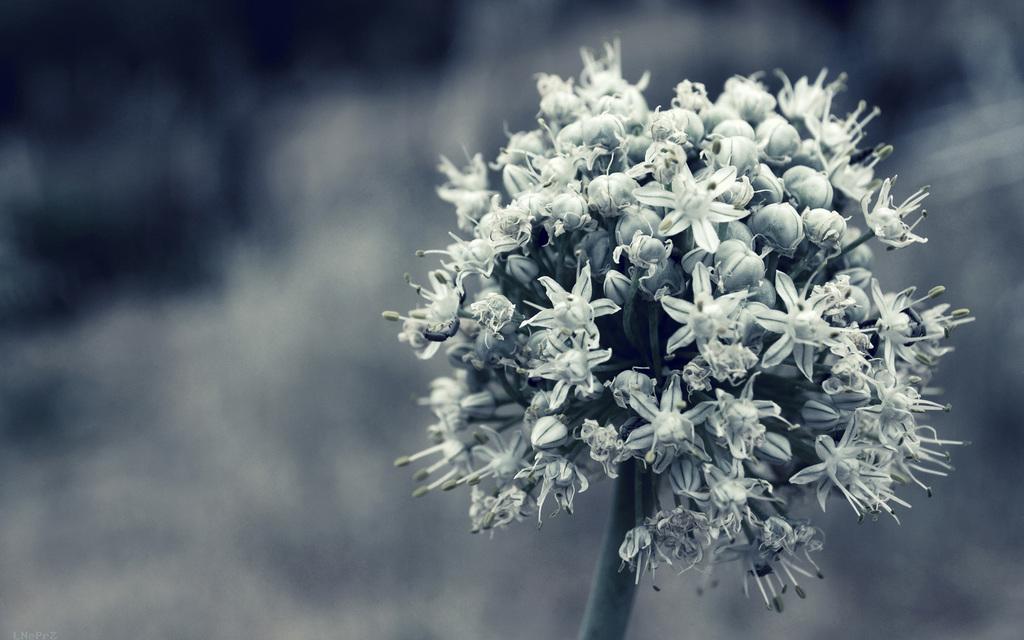Can you describe this image briefly? In this image I can see a flower. The background is blurred. 